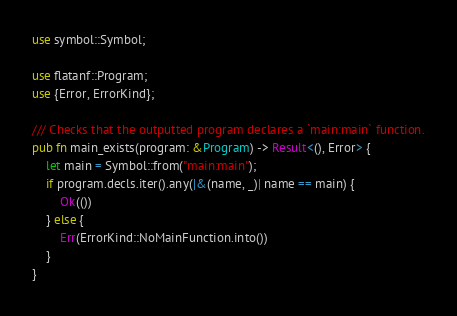Convert code to text. <code><loc_0><loc_0><loc_500><loc_500><_Rust_>use symbol::Symbol;

use flatanf::Program;
use {Error, ErrorKind};

/// Checks that the outputted program declares a `main:main` function.
pub fn main_exists(program: &Program) -> Result<(), Error> {
    let main = Symbol::from("main:main");
    if program.decls.iter().any(|&(name, _)| name == main) {
        Ok(())
    } else {
        Err(ErrorKind::NoMainFunction.into())
    }
}
</code> 